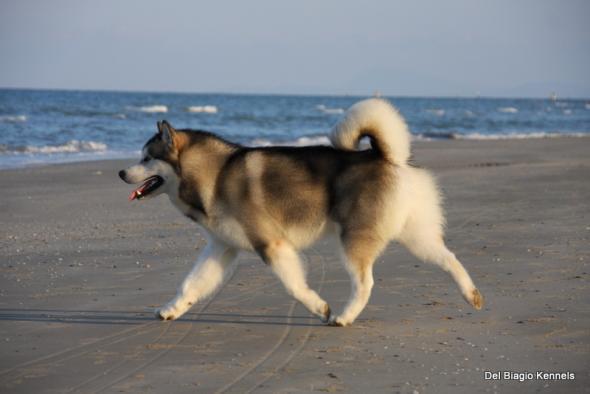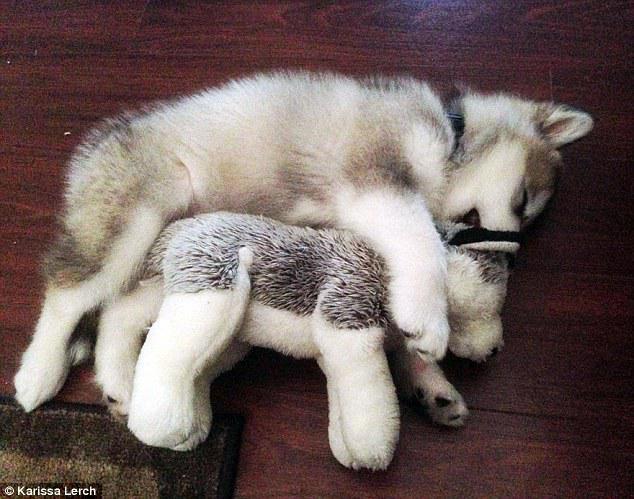The first image is the image on the left, the second image is the image on the right. For the images displayed, is the sentence "The left image includes a husky reclining with its head to the right, and the right image includes a husky reclining with front paws forward." factually correct? Answer yes or no. No. 